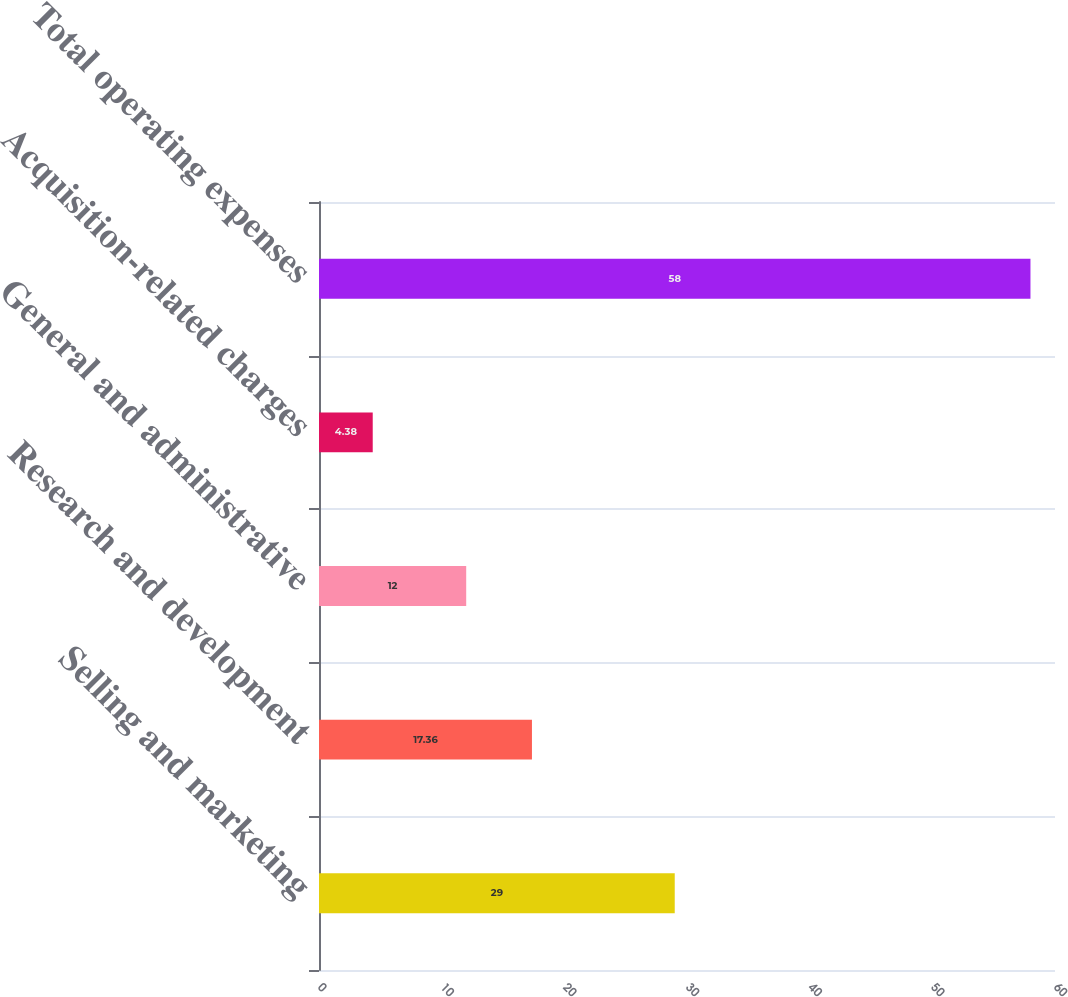Convert chart to OTSL. <chart><loc_0><loc_0><loc_500><loc_500><bar_chart><fcel>Selling and marketing<fcel>Research and development<fcel>General and administrative<fcel>Acquisition-related charges<fcel>Total operating expenses<nl><fcel>29<fcel>17.36<fcel>12<fcel>4.38<fcel>58<nl></chart> 